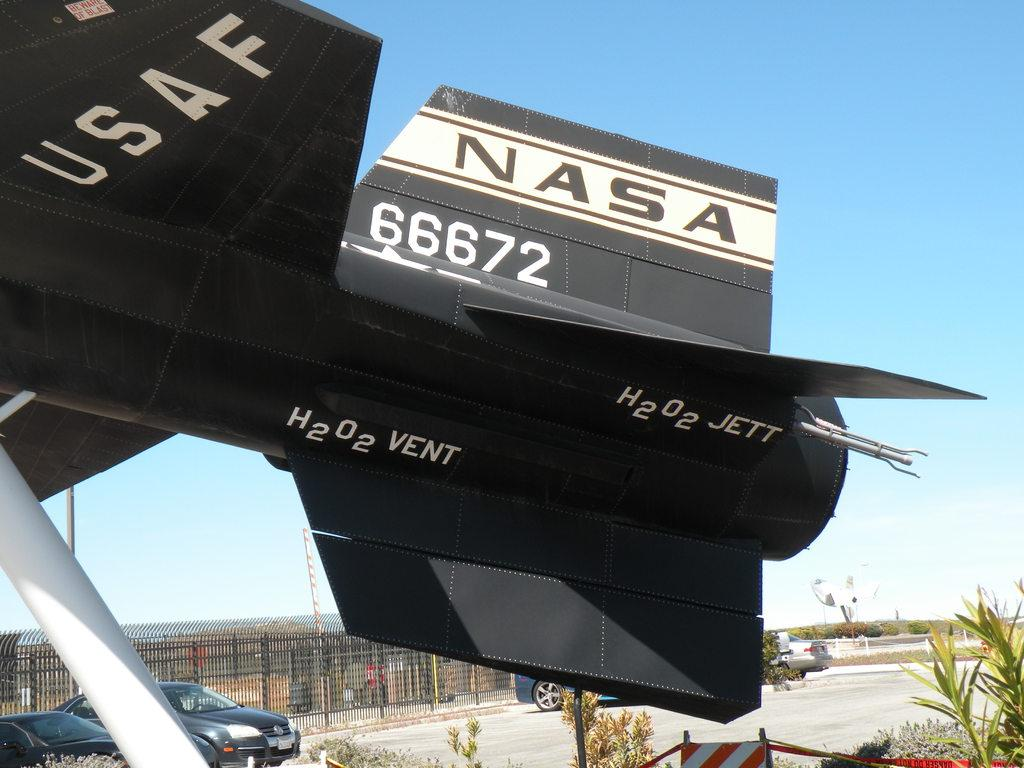<image>
Offer a succinct explanation of the picture presented. A USAF aircraft with NASA 66672 on the tail 